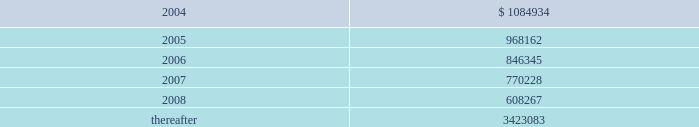Vornado realty trust 77 cash flows the company expects to contribute $ 959000 to the plans in 2004 .
11 .
Leases as lessor : the company leases space to tenants under operating leases .
Most of the leases provide for the payment of fixed base rentals payable monthly in advance .
Shopping center leases provide for the pass-through to tenants of real estate taxes , insurance and maintenance .
Office building leases generally require the tenants to reimburse the company for operating costs and real estate taxes above their base year costs .
Shopping center leases also provide for the payment by the lessee of additional rent based on a percentage of the tenants 2019 sales .
As of december 31 , 2003 , future base rental revenue under non-cancelable operating leases , excluding rents for leases with an original term of less than one year and rents resulting from the exercise of renewal options , is as follows : ( amounts in thousands ) year ending december 31: .
These amounts do not include rentals based on tenants 2019 sales .
These percentage rents approximated $ 3662000 , $ 1832000 , and $ 2157000 , for the years ended december 31 , 2003 , 2002 , and 2001 .
Except for the u.s .
Government , which accounted for 12.7% ( 12.7 % ) of the company 2019s revenue , none of the company 2019s tenants represented more than 10% ( 10 % ) of total revenues for the year ended december 31 , 2003 .
Former bradlees locations property rentals for the year ended december 31 , 2003 , include $ 5000000 of additional rent which , effective december 31 , 2002 , was re-allocated to the former bradlees locations in marlton , turnersville , bensalem and broomall and is payable by stop & shop , pursuant to the master agreement and guaranty , dated may 1 , 1992 .
This amount is in addition to all other rent guaranteed by stop & shop for the former bradlees locations .
On january 8 , 2003 , stop & shop filed a complaint with the united states district court claiming the company has no right to reallocate and therefore continue to collect the $ 5000000 of annual rent from stop & shop because of the expiration of the east brunswick , jersey city , middletown , union and woodbridge leases to which the $ 5000000 of additional rent was previously allocated .
The company believes the additional rent provision of the guaranty expires at the earliest in 2012 and will vigorously oppose stop & shop 2019s complaint .
In february 2003 , koninklijke ahold nv , parent of stop & shop , announced that it overstated its 2002 and 2001 earnings by at least $ 500 million and is under investigation by the u.s .
Justice department and securities and exchange commission .
The company cannot predict what effect , if any , this situation may have on stop & shop 2019s ability to satisfy its obligation under the bradlees guarantees and rent for existing stop & shop leases aggregating approximately $ 10.5 million per annum .
Notes to consolidated financial statements sr-176_fin_l02p53_82v1.qxd 4/8/04 2:42 pm page 77 .
As of 2003 , future noncancelable minimum rent amounts for 2004 and 2005 totaled what , in thousands? 
Computations: (1084934 + 968162)
Answer: 2053096.0. 